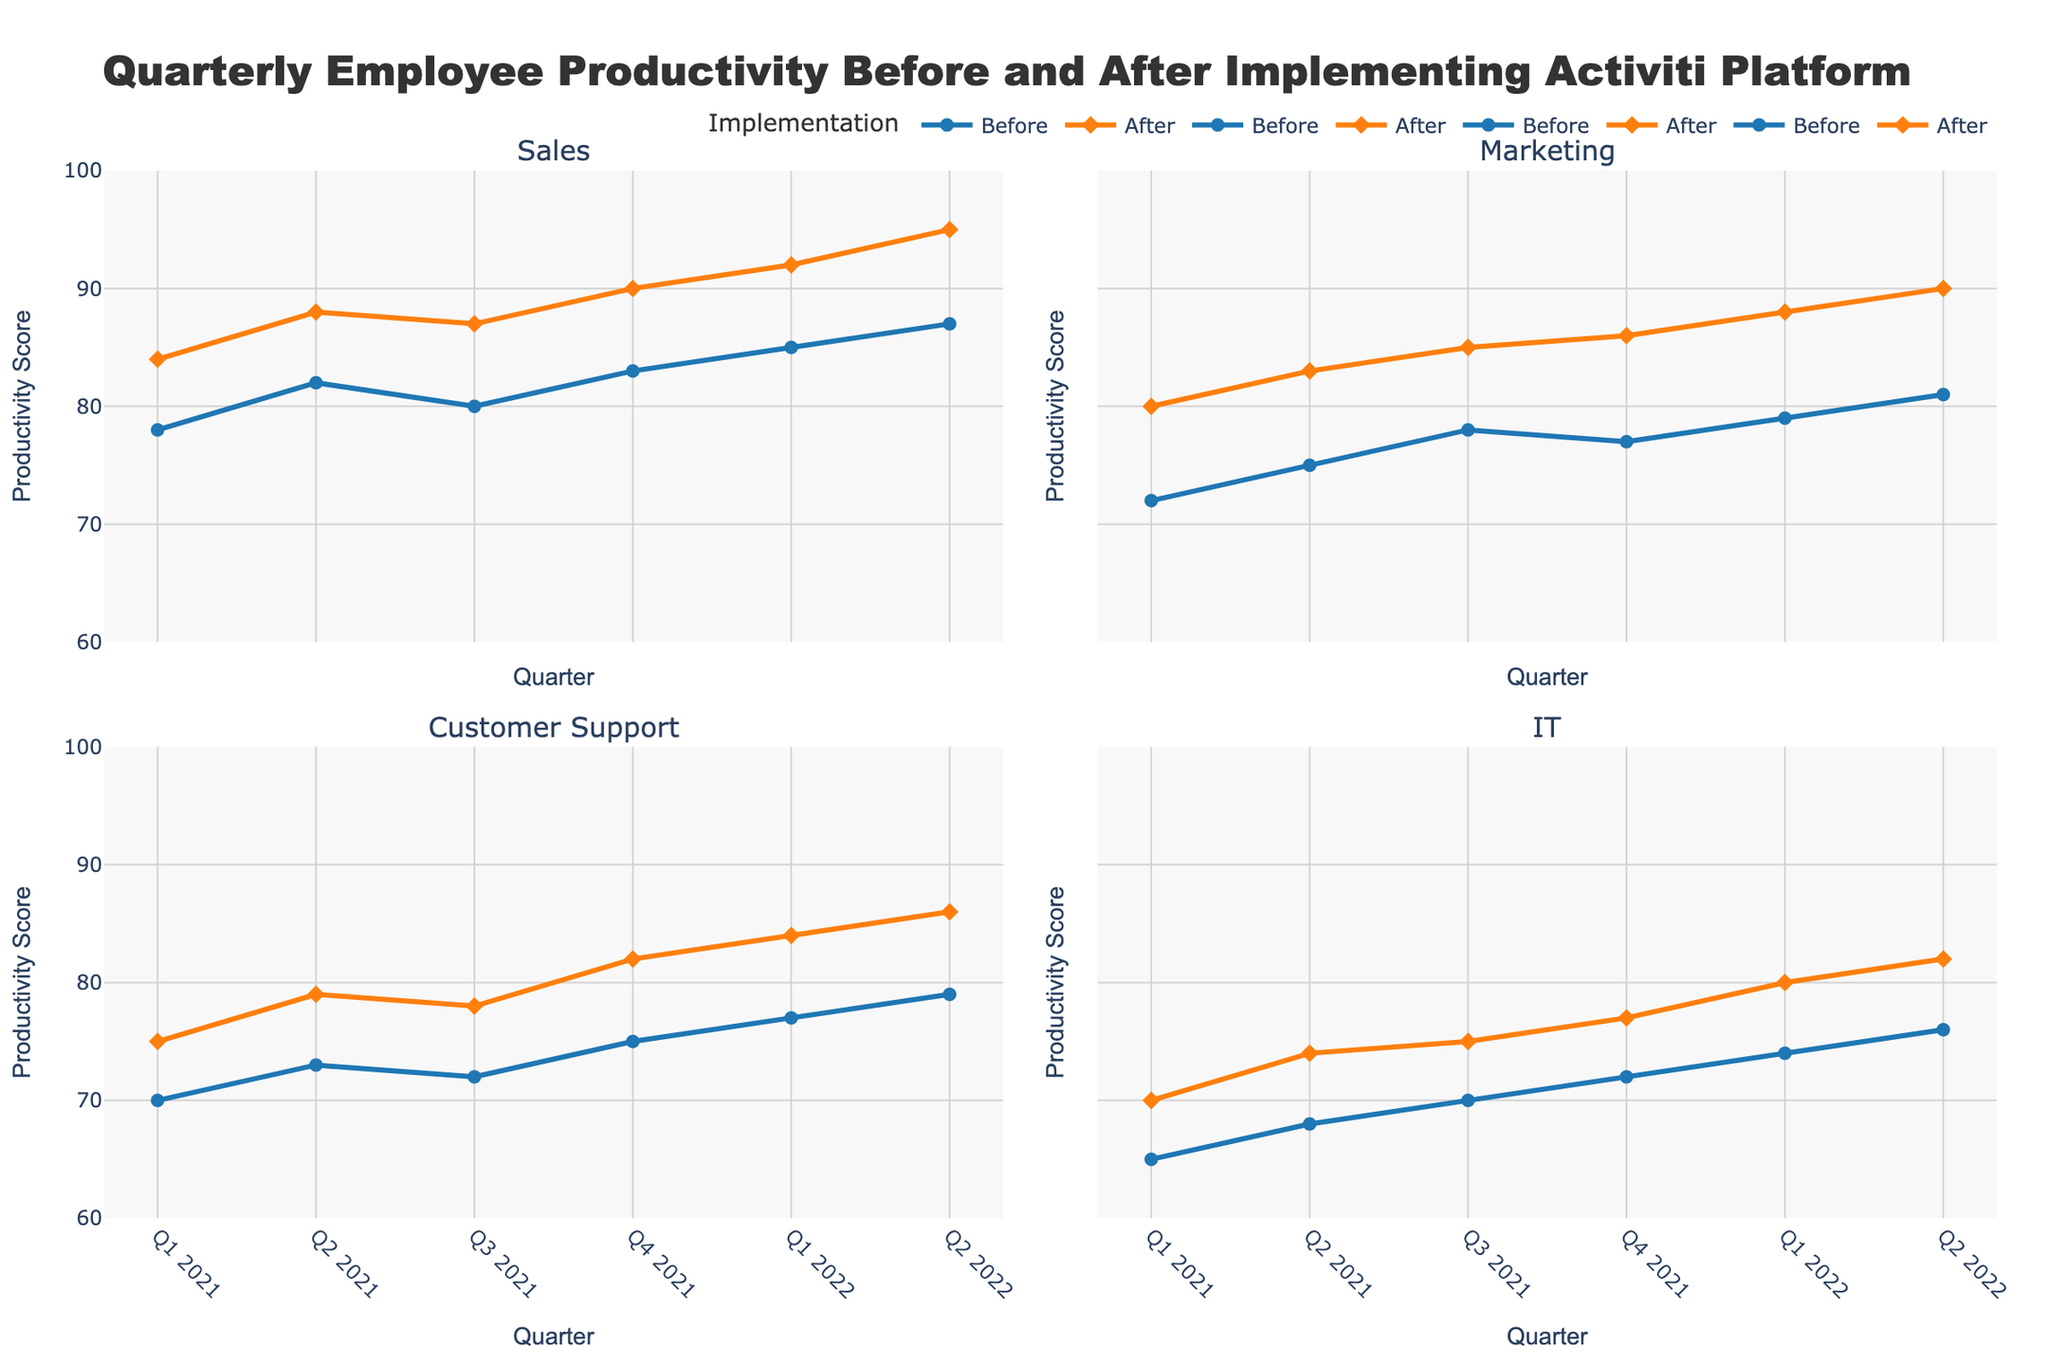How many quarters are displayed in each subplot? There are 6 quarters displayed in each subplot, from Q1 2021 to Q2 2022.
Answer: 6 Which department showed the highest increase in productivity after implementing the Activiti Platform in Q1 2022 compared to Q1 2021? Evaluate the increase for each department from Q1 2021 to Q1 2022: Sales increased by 8 (92-84), Marketing by 8 (88-80), Customer Support by 9 (84-75), IT by 10 (80-70). The IT department has the highest increase.
Answer: IT What is the average productivity score for the Sales department before and after implementation across all quarters? Calculate the average before and after across all quarters for the Sales department: Before = (78+82+80+83+85+87)/6 = 82.5, After = (84+88+87+90+92+95)/6 = 89.33.
Answer: 82.5 (Before), 89.33 (After) How does the productivity trend for the Marketing department compare before and after implementing the Activiti platform? Observe the trend in both series: Before shows a fluctuating trend (72, 75, 78, 77, 79, 81), After shows an upward trend (80, 83, 85, 86, 88, 90).
Answer: Before: Fluctuating, After: Upward Which quarter showed the biggest single-quarter productivity increase for the Customer Support department after implementation? Compare productivity changes between consecutive quarters after implementation: Q1 2021-Q2 2021 = 79-75=4, Q2 2021-Q3 2021 = 78-79=-1, Q3 2021-Q4 2021 = 82-78=4, Q4 2021-Q1 2022 = 84-82=2. The biggest increase is from Q4 2021 to Q1 2022 with 4 units.
Answer: Q1 2022 What is the difference in productivity scores between Q2 2021 and Q2 2022 for the IT department after implementation? Subtract Q2 2021 after implementation value from Q2 2022 after implementation value: 82 - 74 = 8.
Answer: 8 How does the range of productivity scores before implementation for the IT department compare to Customer Support? Calculate the range as maximum value - minimum value: IT before = 76 - 65 = 11, Customer Support before = 79 - 70 = 9. The IT department has a wider range.
Answer: IT: 11, Customer Support: 9 What four subplots are included in the chart, and how are they arranged? The four subplots represent Sales, Marketing, Customer Support, and IT departments. They are arranged in a 2x2 grid.
Answer: Sales, Marketing, Customer Support, IT 